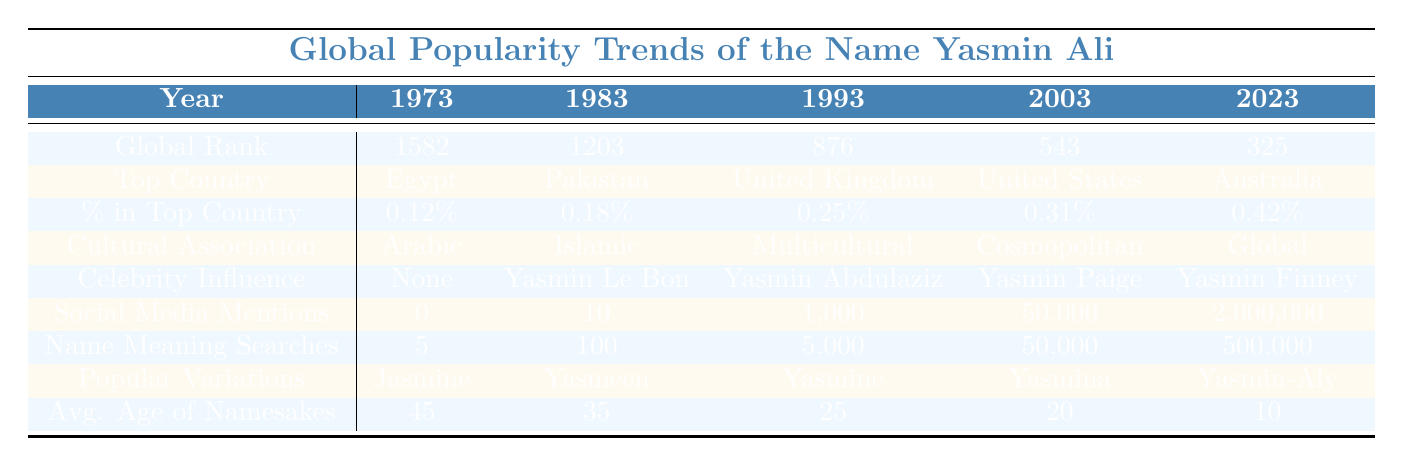What was the global popularity rank of Yasmin Ali in 2023? In the table, under the "Global Rank" row for the year 2023, the value listed is 325.
Answer: 325 Which country had the highest percentage of the name Yasmin Ali in 2023? The "Top Country" for 2023 is Australia according to the table. It shows that Australia's percentage in this year is 0.42%.
Answer: Australia How many social media mentions were there for Yasmin Ali in 2003? In the table, the "Social Media Mentions" for the year 2003 is listed as 50,000.
Answer: 50,000 What is the average age of namesakes for Yasmin Ali in 1973? The average age of namesakes in 1973 is given in the table as 45 years.
Answer: 45 Is there a notable celebrity influence on the popularity of Yasmin Ali in 2023? According to the table, the celebrity influence listed for 2023 is Yasmin Finney, indicating that there is a notable influence in this year.
Answer: Yes Which year saw the most significant increase in social media mentions from the previous decade? Comparing 1993 (1,000 mentions) to 2003 (50,000 mentions) shows an increase of 49,000 mentions, which is the greatest increase.
Answer: 2003 What is the percentage increase in Yasmin Ali's popularity rank from 2003 to 2023? The rank in 2003 is 543 and in 2023 is 325. To find the percentage change: (543 - 325) / 543 * 100 ≈ 40%.
Answer: 40% Which cultural association is linked to Yasmin Ali in 2013? The table states that the cultural association for the year 2013 is "Modern."
Answer: Modern How does the popularity of Yasmin Ali compare between 1973 and 2023 in terms of global rank? In 1973, the rank was 1582, and in 2023, it was 325. This indicates a significant improvement in popularity rank over the 50 years.
Answer: Improved What were the popular variations of the name Yasmin Ali in 1993? The table lists "Yasmine" as one of the popular variations for the year 1993.
Answer: Yasmine 